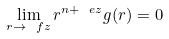<formula> <loc_0><loc_0><loc_500><loc_500>\lim _ { r \to \ f z } r ^ { n + \ e z } g ( r ) = 0</formula> 